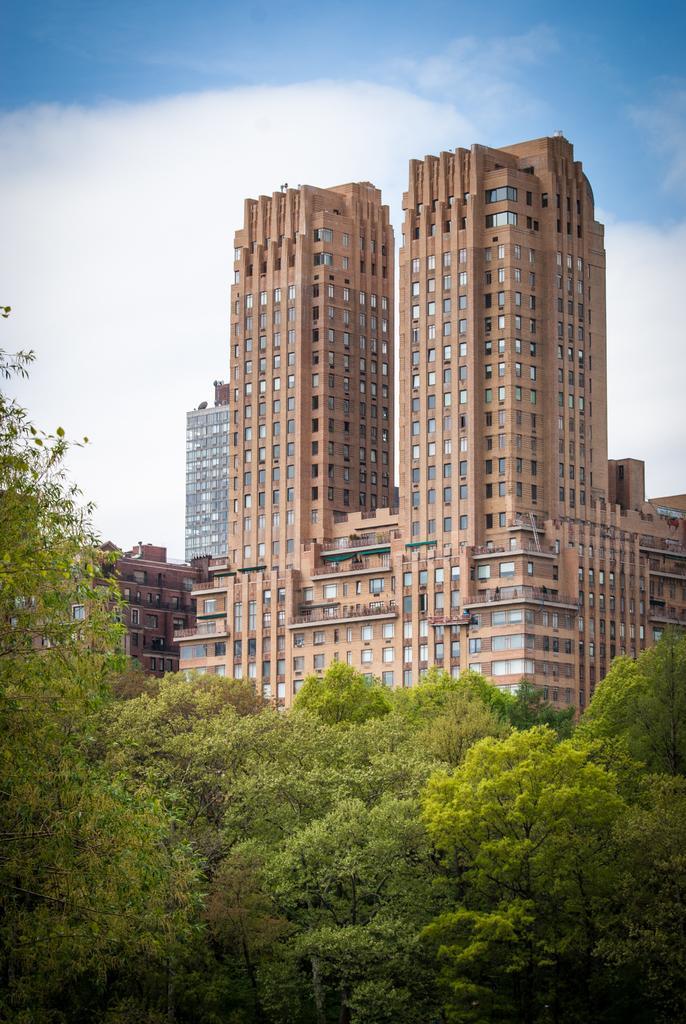How would you summarize this image in a sentence or two? In this image I see number of buildings and number of trees over here and in the background I see the clear sky. 